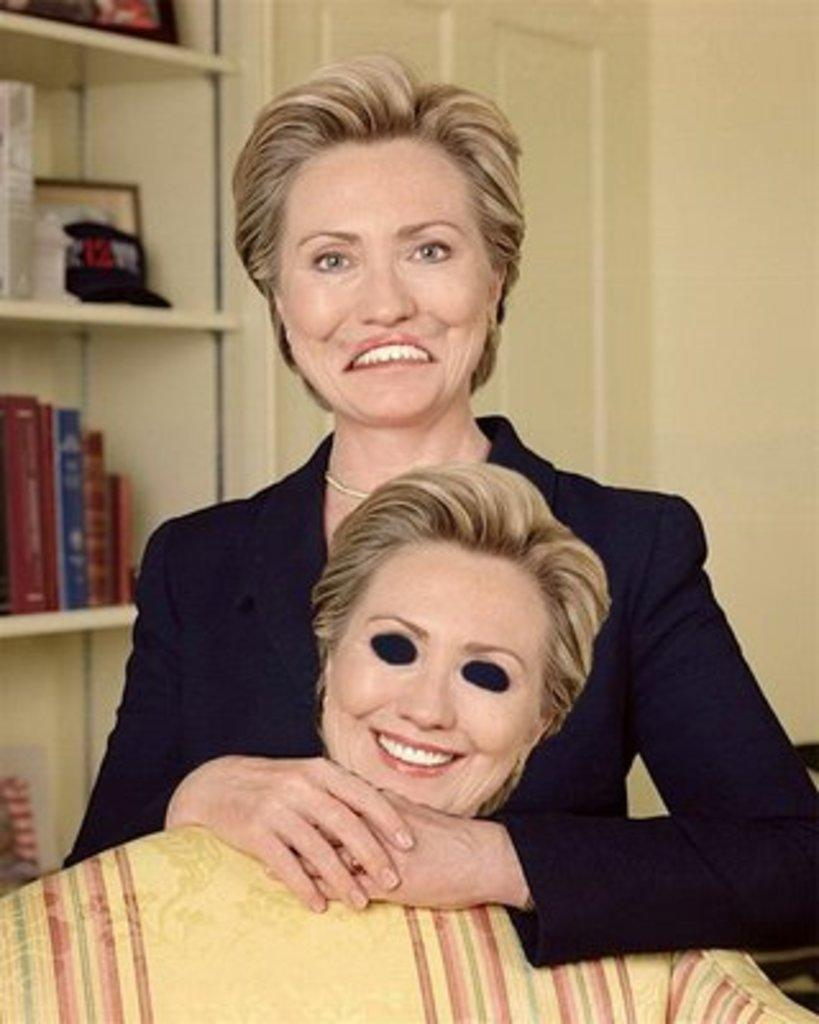Who is the main subject in the image? There is a woman in the image. What is the woman doing in the image? The woman is standing. What is the woman wearing in the image? The woman is wearing a black dress. What can be seen behind the woman in the image? There is a rack behind the woman. What is on the rack in the image? Books and other things are arranged on the rack. What is the cause of the thumb's position on the woman's neck in the image? There is no thumb or neck mentioned in the image; the woman is wearing a black dress and standing near a rack with books and other items. 